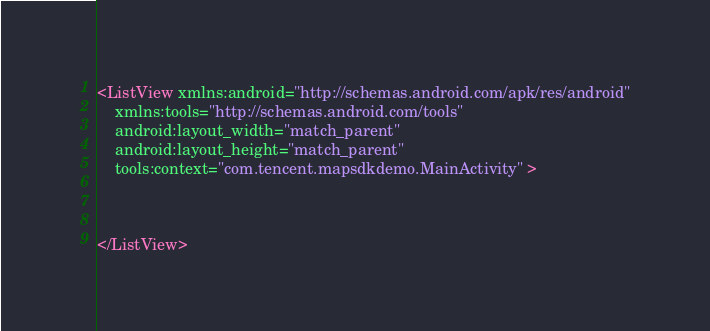<code> <loc_0><loc_0><loc_500><loc_500><_XML_><ListView xmlns:android="http://schemas.android.com/apk/res/android"
    xmlns:tools="http://schemas.android.com/tools"
    android:layout_width="match_parent"
    android:layout_height="match_parent"
    tools:context="com.tencent.mapsdkdemo.MainActivity" >

    

</ListView>
</code> 